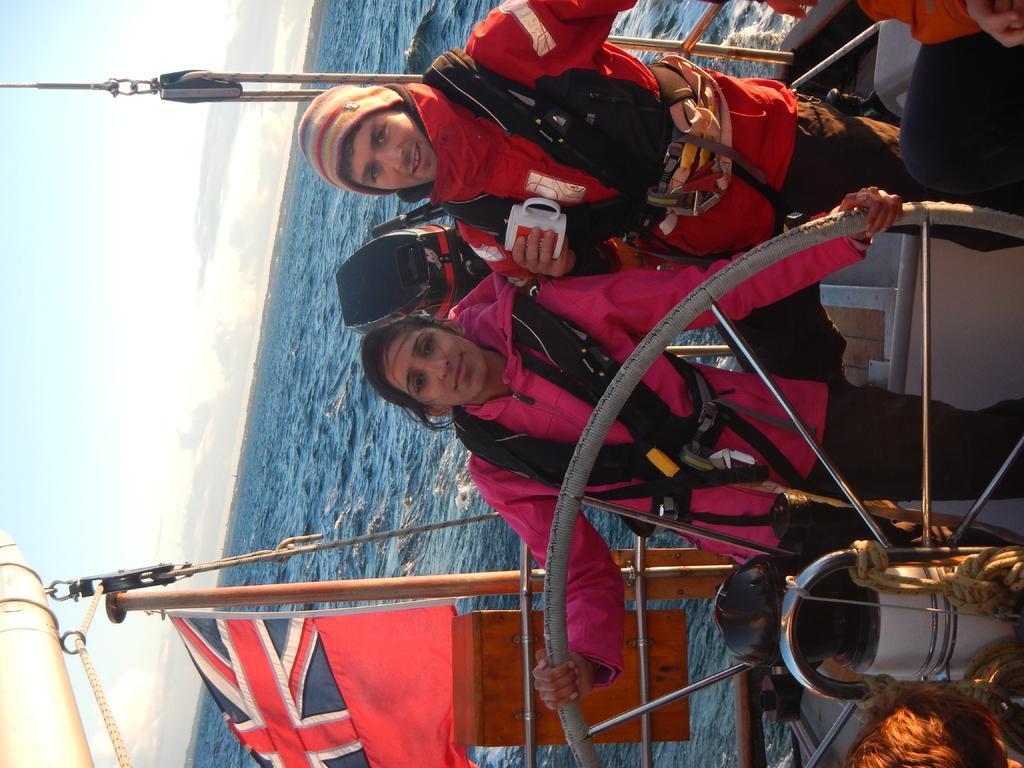In one or two sentences, can you explain what this image depicts? In the picture I can see a person wearing a black jacket, cap is holding a cup in his hands and we can see a woman wearing pink color jacket is standing here. Here we can see a flag, few objects and we can see they are standing in the boat which is floating on the water. In the background, I can see the cloudy sky. 